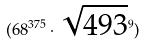Convert formula to latex. <formula><loc_0><loc_0><loc_500><loc_500>( 6 8 ^ { 3 7 5 } \cdot \sqrt { 4 9 3 } ^ { 9 } )</formula> 